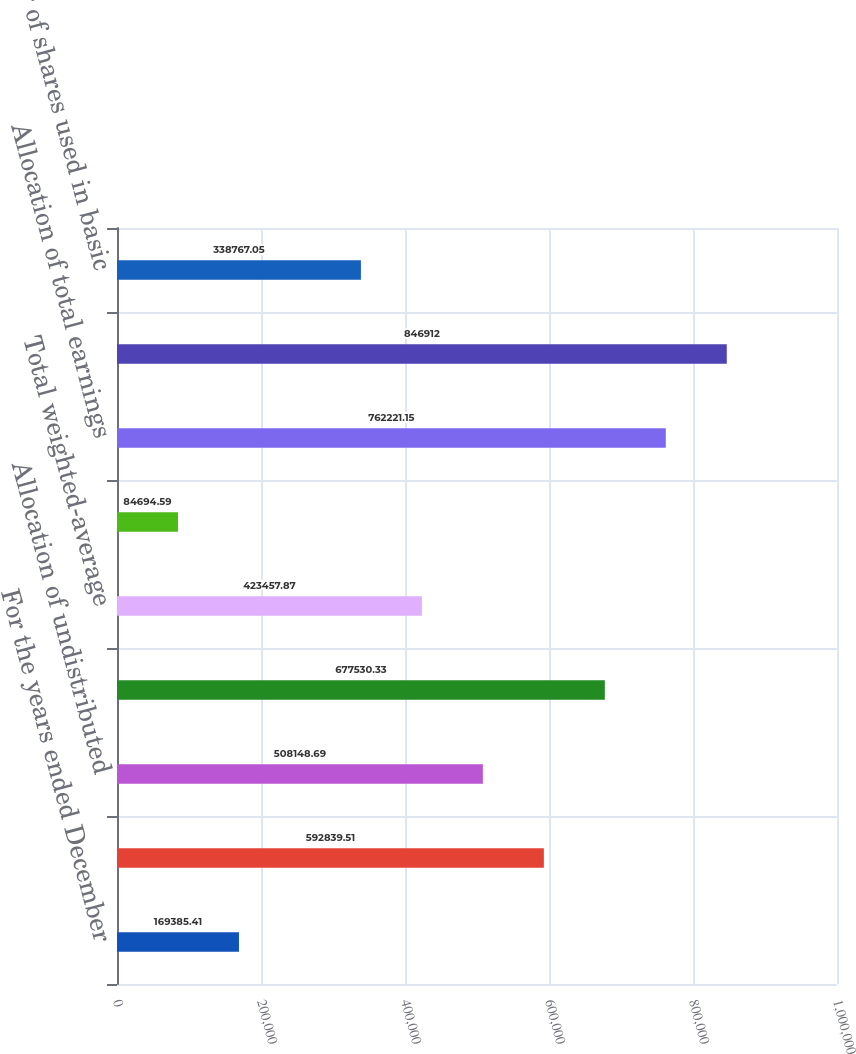<chart> <loc_0><loc_0><loc_500><loc_500><bar_chart><fcel>For the years ended December<fcel>Allocation of distributed<fcel>Allocation of undistributed<fcel>Total earnings-basic<fcel>Total weighted-average<fcel>Earnings Per Share-basic<fcel>Allocation of total earnings<fcel>Total earnings-diluted<fcel>Number of shares used in basic<nl><fcel>169385<fcel>592840<fcel>508149<fcel>677530<fcel>423458<fcel>84694.6<fcel>762221<fcel>846912<fcel>338767<nl></chart> 